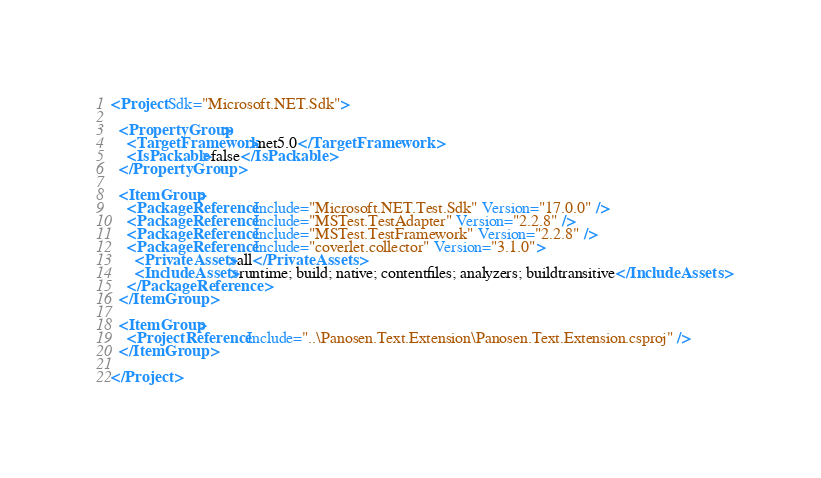<code> <loc_0><loc_0><loc_500><loc_500><_XML_><Project Sdk="Microsoft.NET.Sdk">

  <PropertyGroup>
    <TargetFramework>net5.0</TargetFramework>
    <IsPackable>false</IsPackable>
  </PropertyGroup>

  <ItemGroup>
    <PackageReference Include="Microsoft.NET.Test.Sdk" Version="17.0.0" />
    <PackageReference Include="MSTest.TestAdapter" Version="2.2.8" />
    <PackageReference Include="MSTest.TestFramework" Version="2.2.8" />
    <PackageReference Include="coverlet.collector" Version="3.1.0">
      <PrivateAssets>all</PrivateAssets>
      <IncludeAssets>runtime; build; native; contentfiles; analyzers; buildtransitive</IncludeAssets>
    </PackageReference>
  </ItemGroup>

  <ItemGroup>
    <ProjectReference Include="..\Panosen.Text.Extension\Panosen.Text.Extension.csproj" />
  </ItemGroup>

</Project>
</code> 